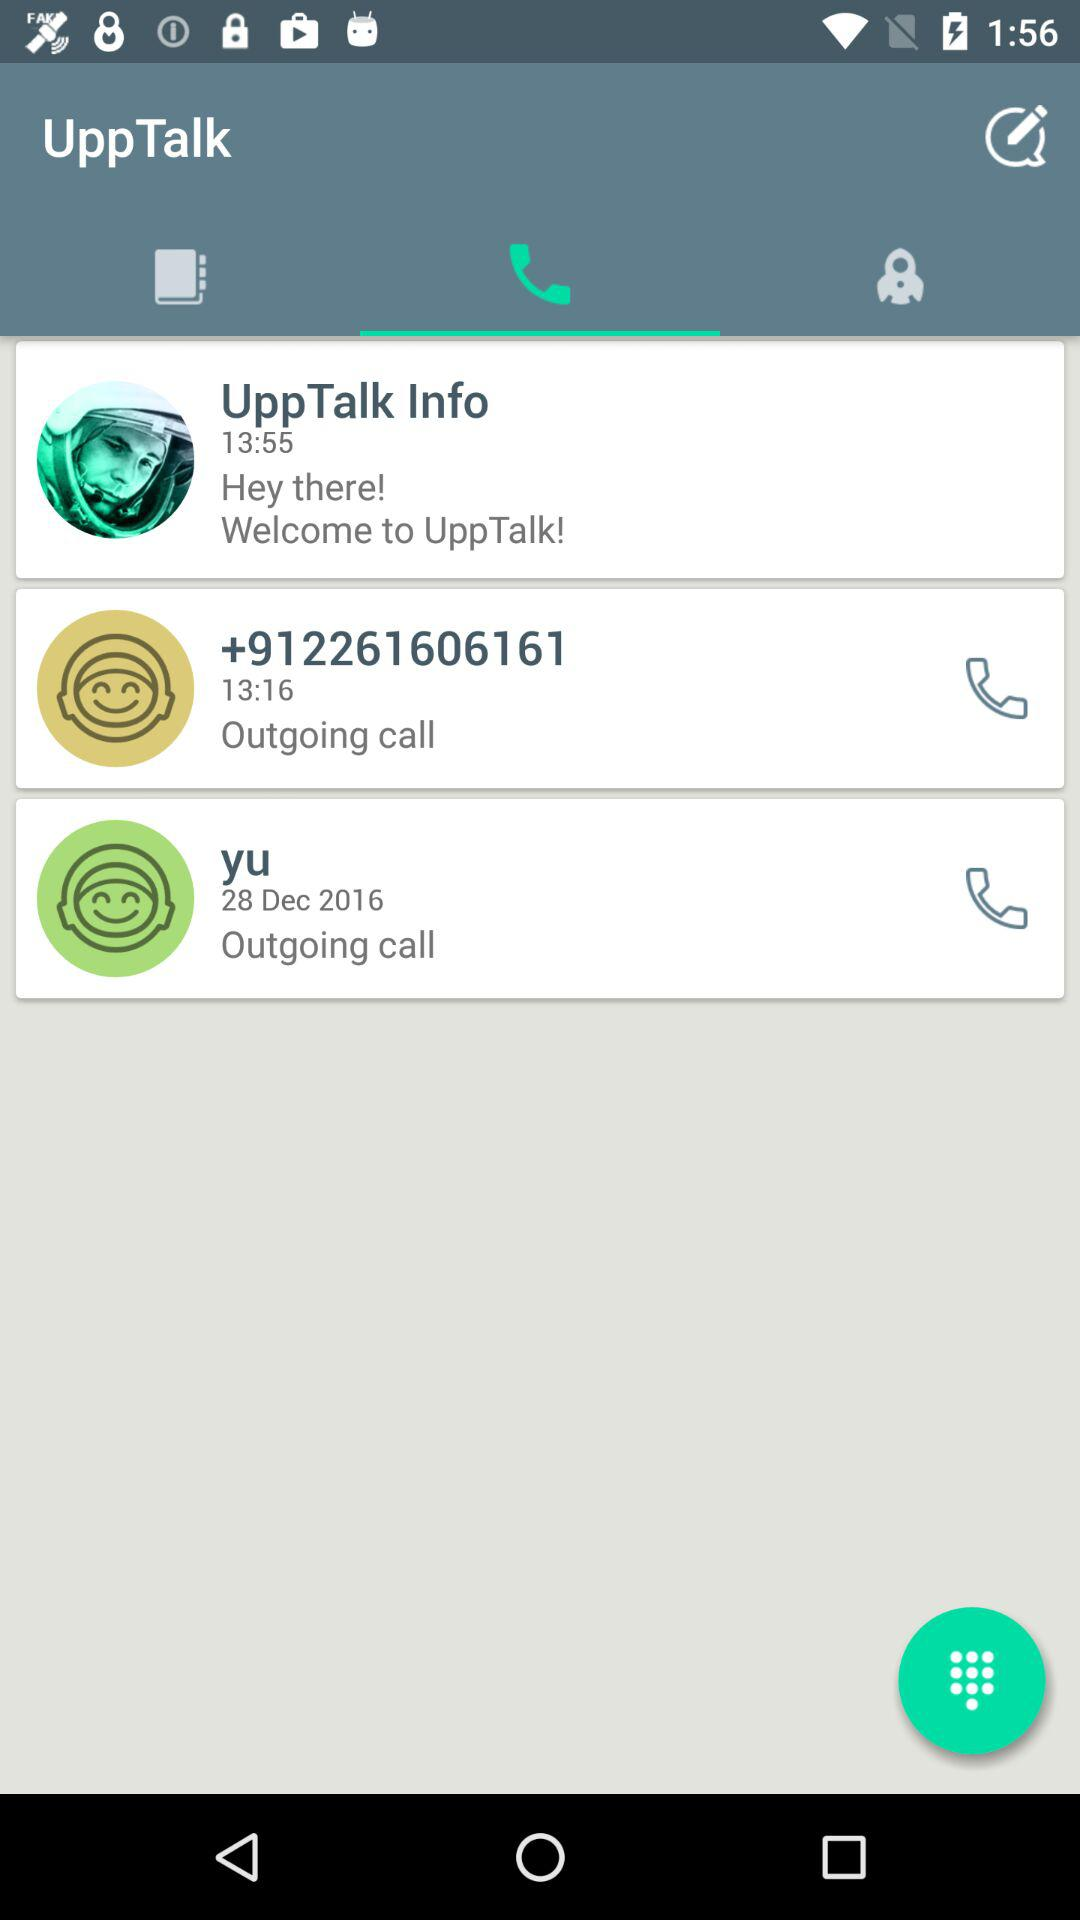What is the contact number to which the call was made? The contact number is +912261606161. 